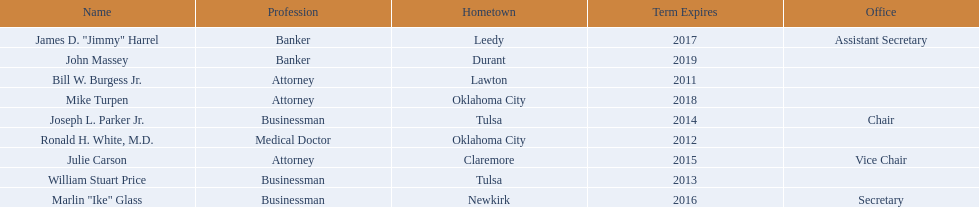What are all of the names? Bill W. Burgess Jr., Ronald H. White, M.D., William Stuart Price, Joseph L. Parker Jr., Julie Carson, Marlin "Ike" Glass, James D. "Jimmy" Harrel, Mike Turpen, John Massey. Where is each member from? Lawton, Oklahoma City, Tulsa, Tulsa, Claremore, Newkirk, Leedy, Oklahoma City, Durant. Along with joseph l. parker jr., which other member is from tulsa? William Stuart Price. 